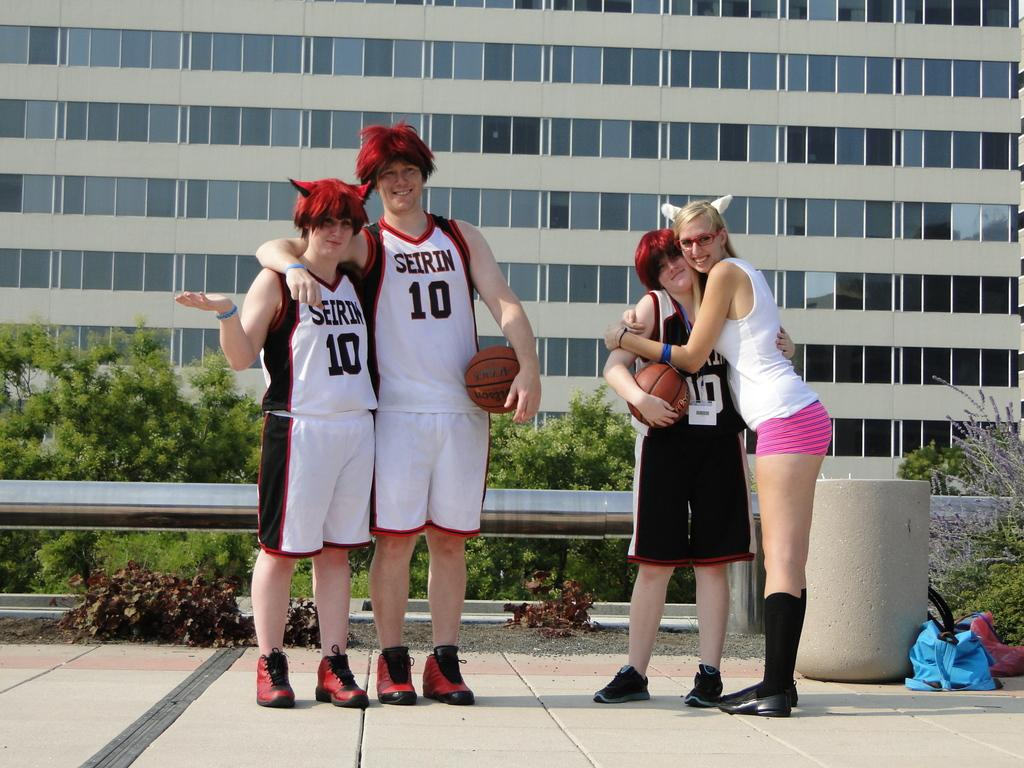Provide a one-sentence caption for the provided image. Three people wearing Seirin basketball jerseys and the number 10 pose for a photo. 